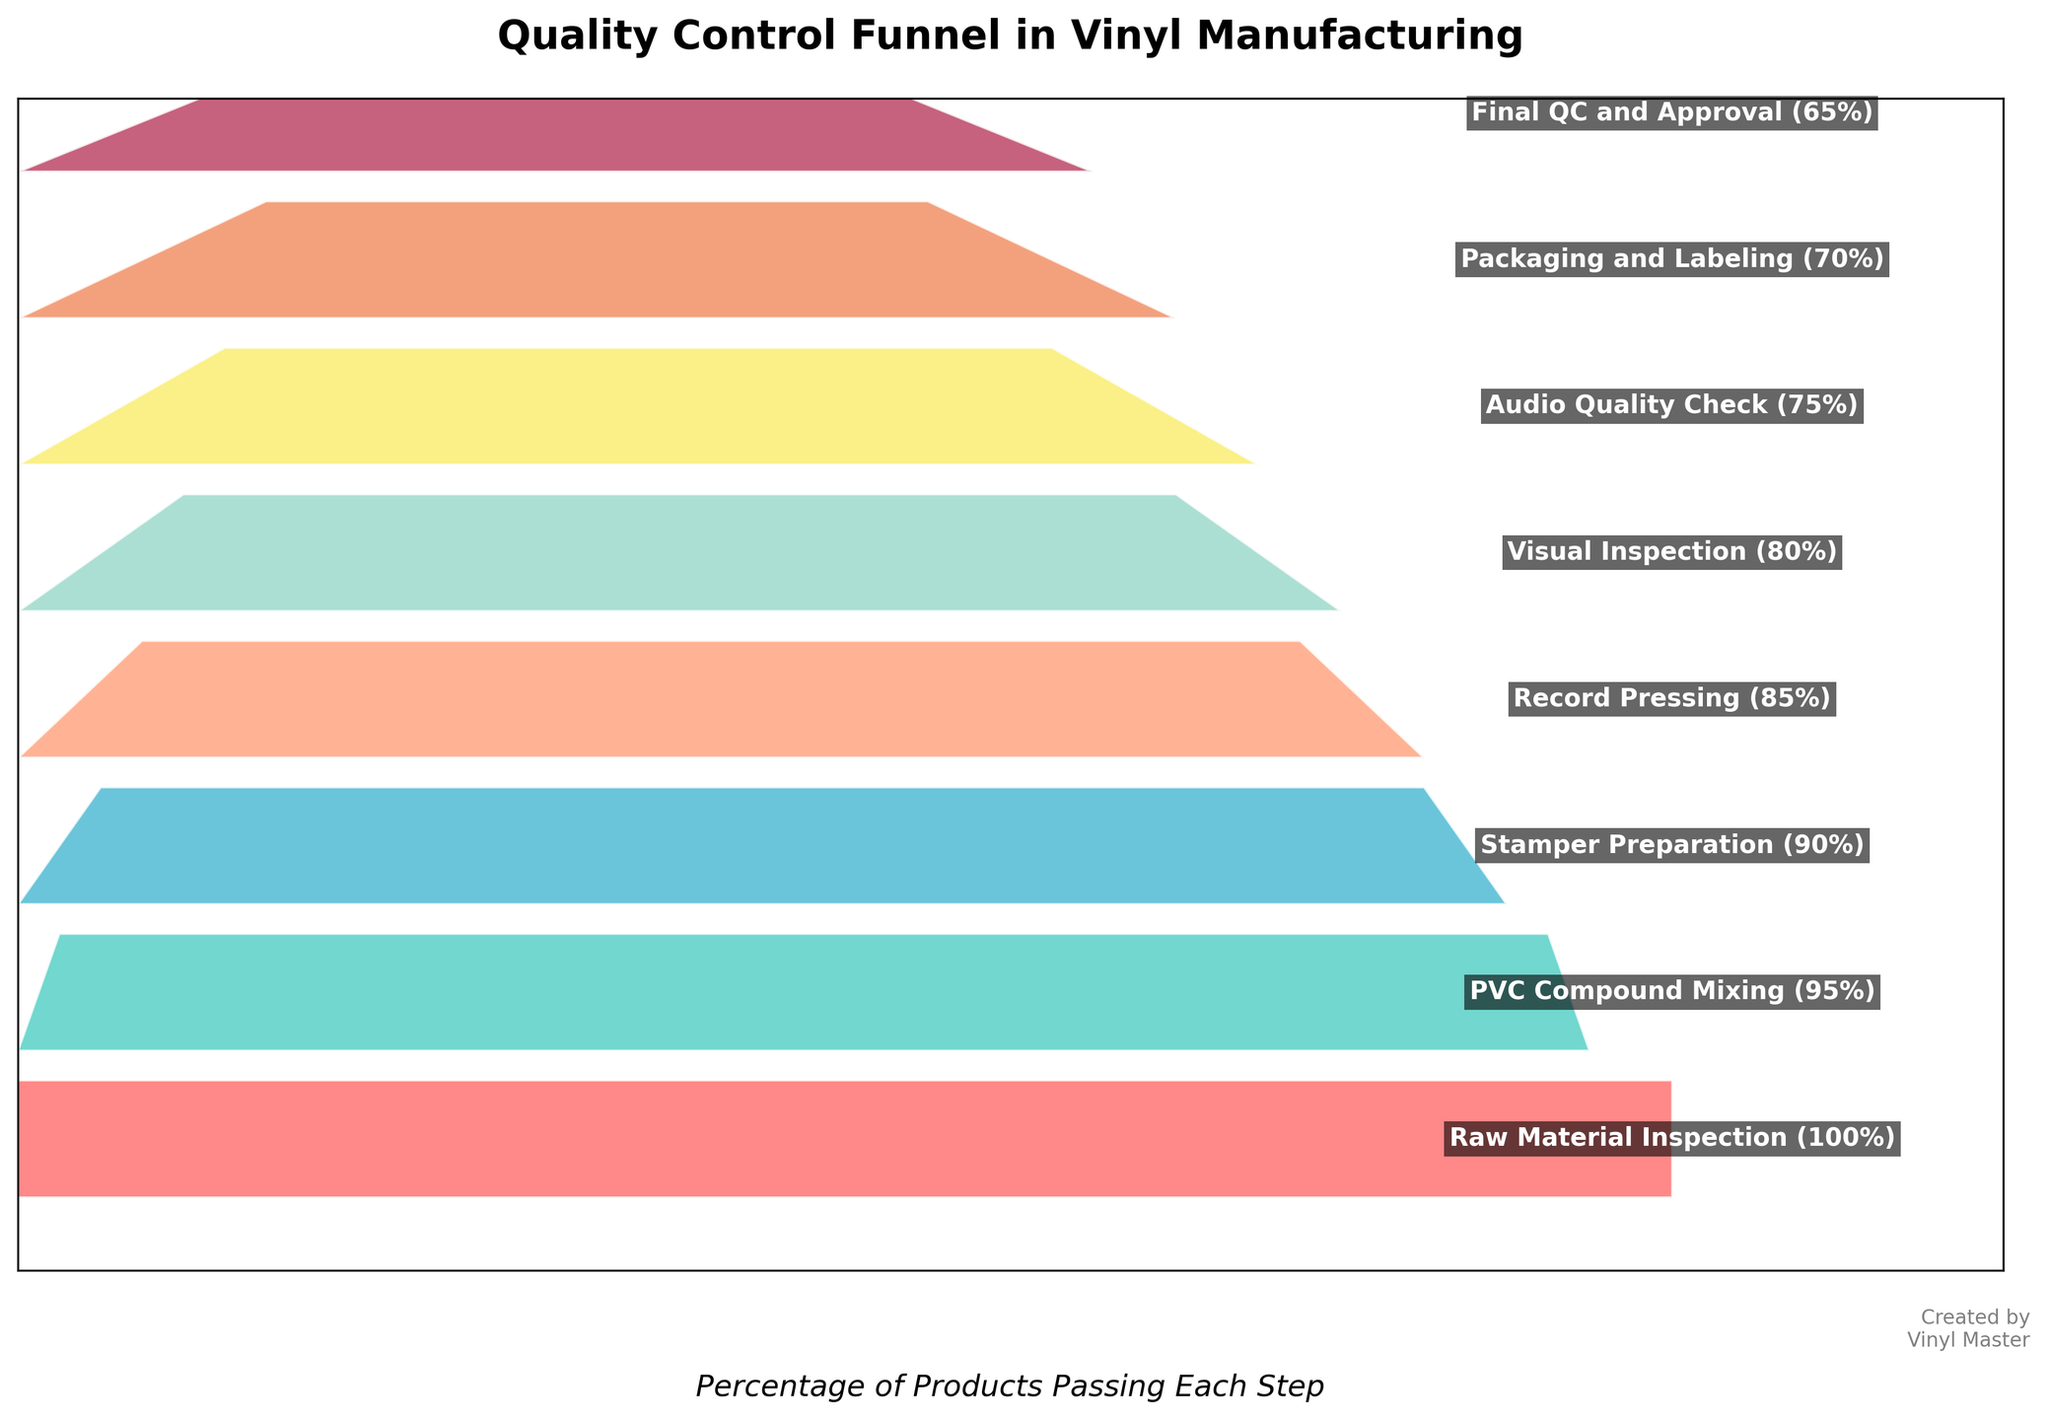what is the title of the chart? The title is usually found at the top of the chart. It summarizes the main subject or purpose of the visualization. Here the title is prominently displayed.
Answer: Quality Control Funnel in Vinyl Manufacturing How many total quality control steps are depicted in the funnel chart? Count the distinct steps shown in the funnel chart from top to bottom.
Answer: 8 What is the final percentage of products passing the last step? Look at the bottom step where it shows the final QC and Approval step and note the percentage next to it.
Answer: 65% Which step has the highest drop-off in product passing rate? Compare the difference in percentages between consecutive steps. The largest difference indicates the highest drop.
Answer: Raw Material Inspection to PVC Compound Mixing What is the drop in percentage from Stamper Preparation to Audio Quality Check? Subtract the percentage at Audio Quality Check from the percentage at Stamper Preparation (90% - 75% = 15%).
Answer: 15% Is the decrease in products passing between each step consistent throughout the process? Evaluate whether the drop-off in percentage between each step is roughly the same. Check for any significant deviations.
Answer: No Which step is immediately before Record Pressing? Identify the step listed just above Record Pressing in the sequence provided.
Answer: Stamper Preparation What is the combined percentage drop from Raw Material Inspection to Visual Inspection? Subtract the percentage at the Visual Inspection step from Raw Material Inspection (100% - 80% = 20%).
Answer: 20% Which steps share the same color shade in the chart? Look for steps that are visually represented with the same or similar color within the chart.
Answer: No steps share the same color Between which two steps does the percentage of products passing drop from 90% to 85%? Identify where the percentages shift from 90% to 85%.
Answer: Stamper Preparation to Record Pressing 